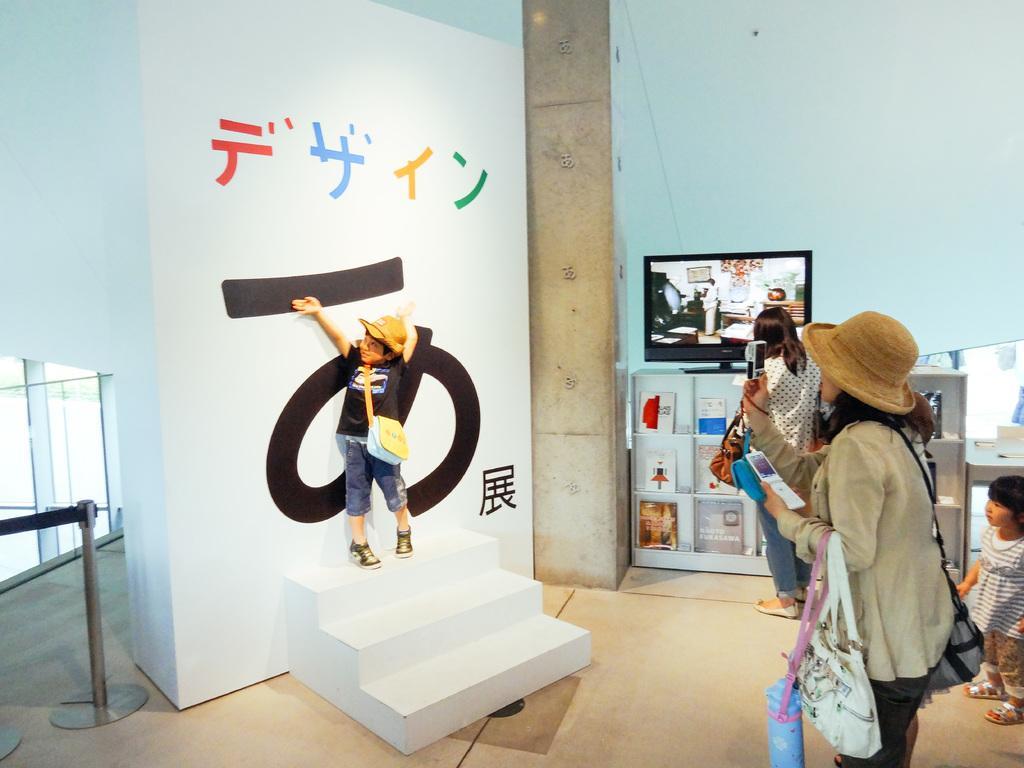In one or two sentences, can you explain what this image depicts? In this image we can see a white object looks like a wall and there are stairs attached to it. On the wall we can see some text and a boy is standing on the stairs. In front of the boy we can see few persons holding objects and among them a person is taking a photo. In the background, we can see a tv on a table and a wall. On the tv we can see some picture. On the right side, we can see a girl. On the left side, we can see a barrier. 